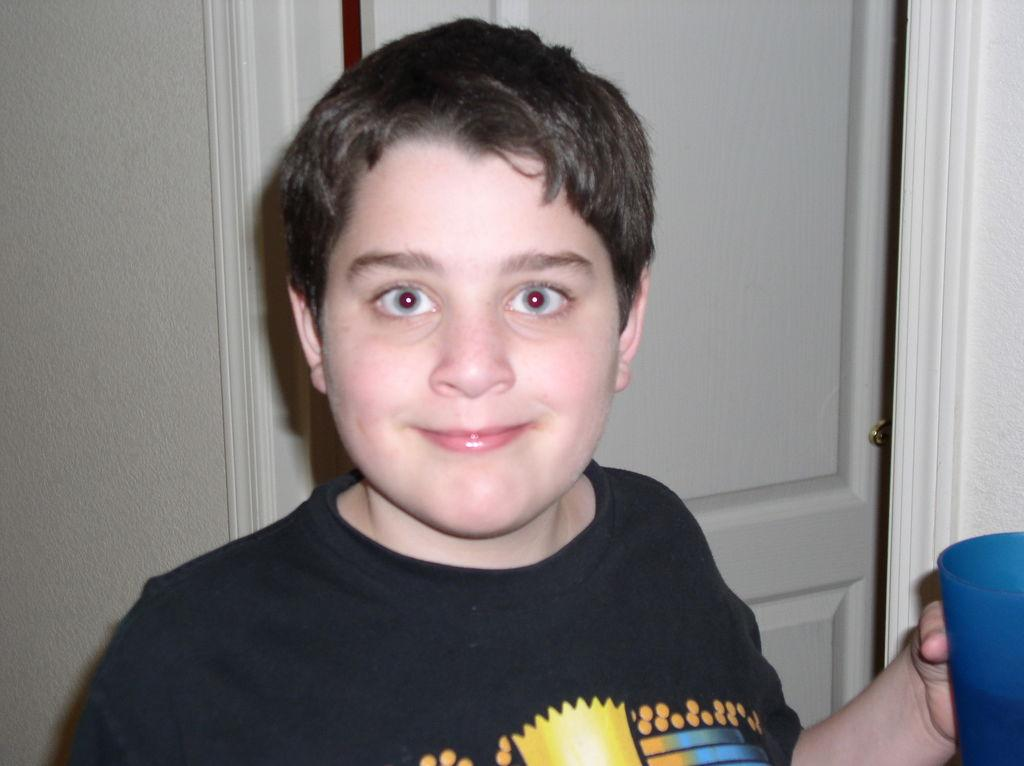Who is the main subject in the image? There is a boy in the image. What is the boy wearing? The boy is wearing a black shirt. What is the boy holding in the image? The boy is holding a cup. What color is the cup? The cup is blue in color. What architectural feature can be seen in the image? There is a door visible in the image. What month is depicted in the image? There is no month depicted in the image; it is a still photograph of a boy holding a blue cup. What type of cork can be seen in the image? There is no cork present in the image. 